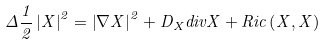Convert formula to latex. <formula><loc_0><loc_0><loc_500><loc_500>\Delta \frac { 1 } { 2 } \left | X \right | ^ { 2 } = \left | \nabla X \right | ^ { 2 } + D _ { X } d i v X + R i c \left ( X , X \right )</formula> 